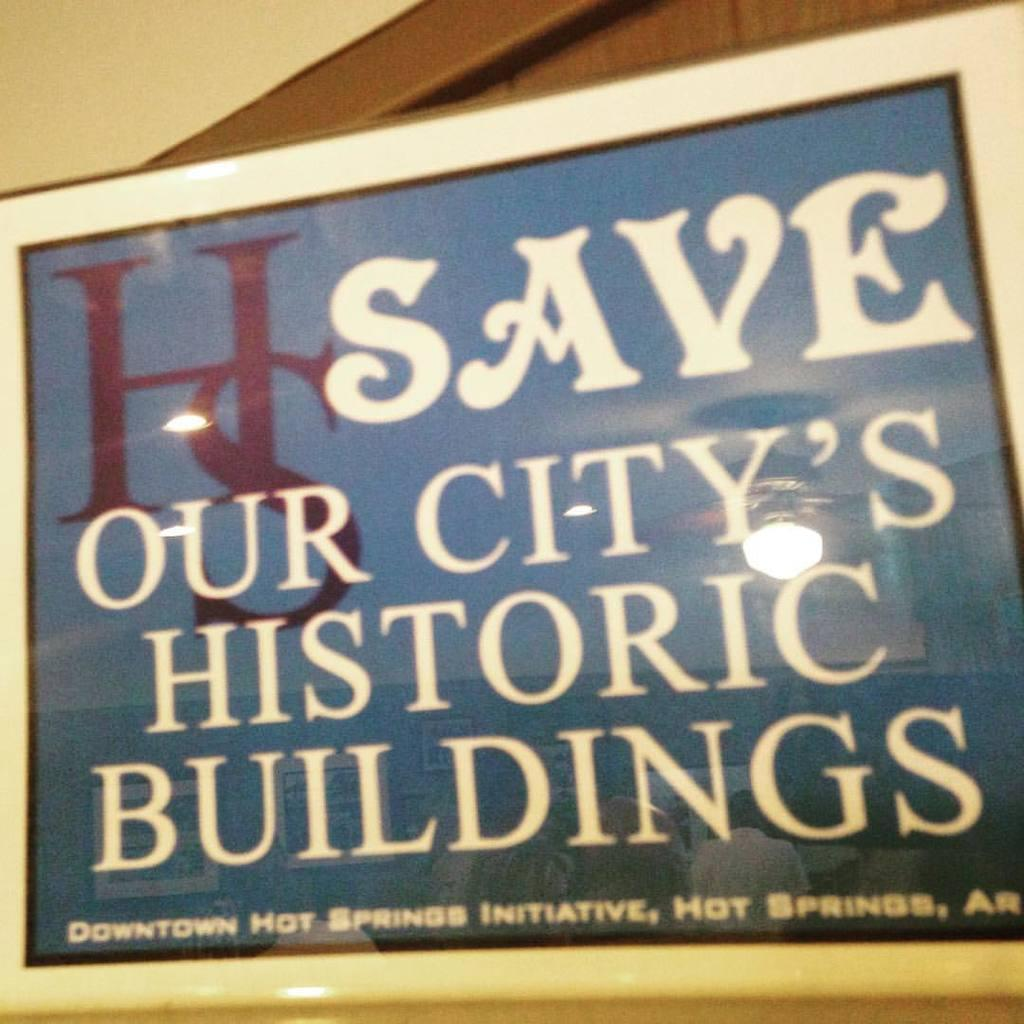<image>
Offer a succinct explanation of the picture presented. A poster with white letters against a blue background calling for saving historic buildings in Hot Spprings Arkansas. 